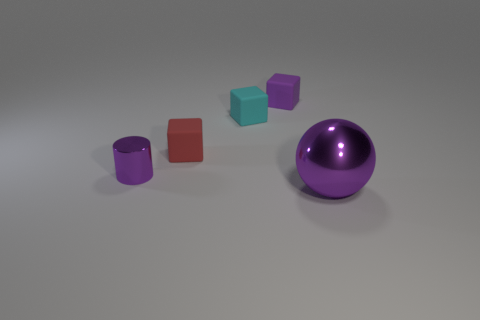Subtract all small purple blocks. How many blocks are left? 2 Add 1 tiny metal objects. How many tiny metal objects exist? 2 Add 3 cyan objects. How many objects exist? 8 Subtract all red blocks. How many blocks are left? 2 Subtract 0 blue cylinders. How many objects are left? 5 Subtract all cubes. How many objects are left? 2 Subtract 2 blocks. How many blocks are left? 1 Subtract all blue blocks. Subtract all brown cylinders. How many blocks are left? 3 Subtract all purple balls. How many red blocks are left? 1 Subtract all small matte balls. Subtract all small red objects. How many objects are left? 4 